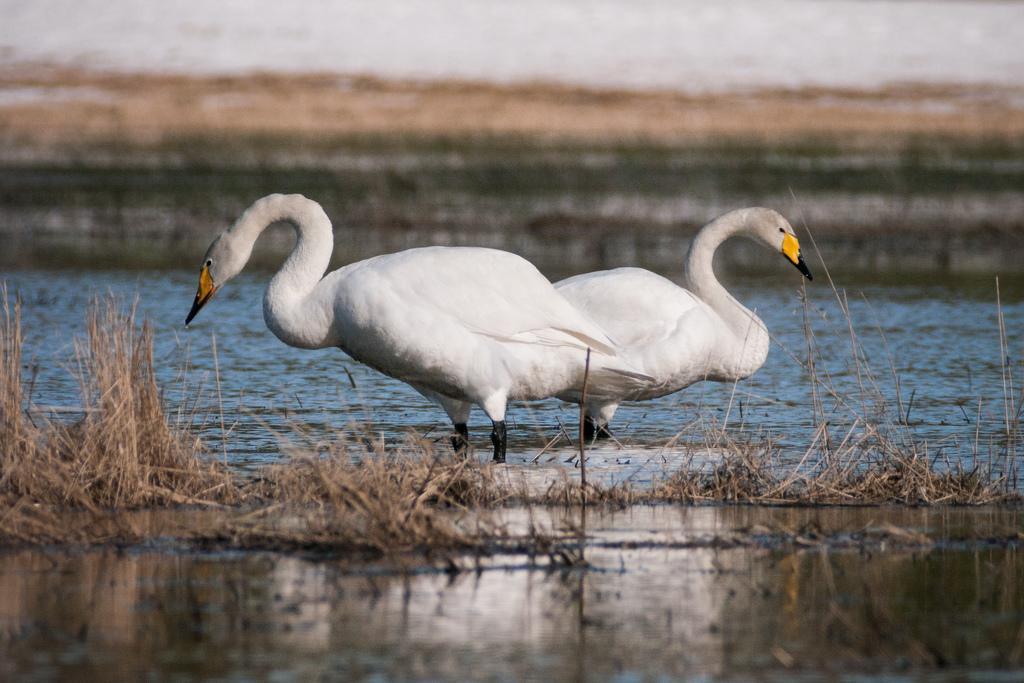Can you describe this image briefly? In this image we can see birds in water. There is dry grass. The background of the image is not clear. 